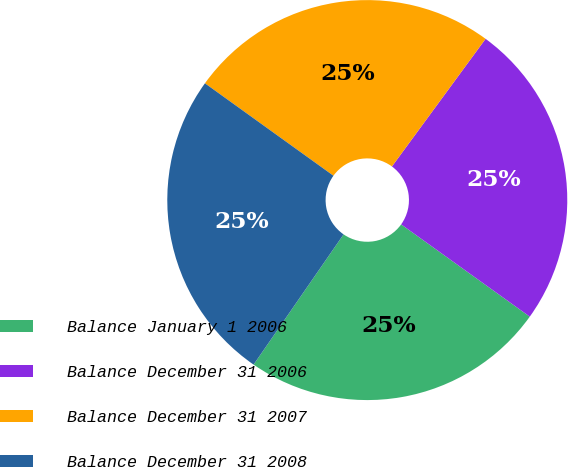Convert chart. <chart><loc_0><loc_0><loc_500><loc_500><pie_chart><fcel>Balance January 1 2006<fcel>Balance December 31 2006<fcel>Balance December 31 2007<fcel>Balance December 31 2008<nl><fcel>24.72%<fcel>24.83%<fcel>25.15%<fcel>25.3%<nl></chart> 